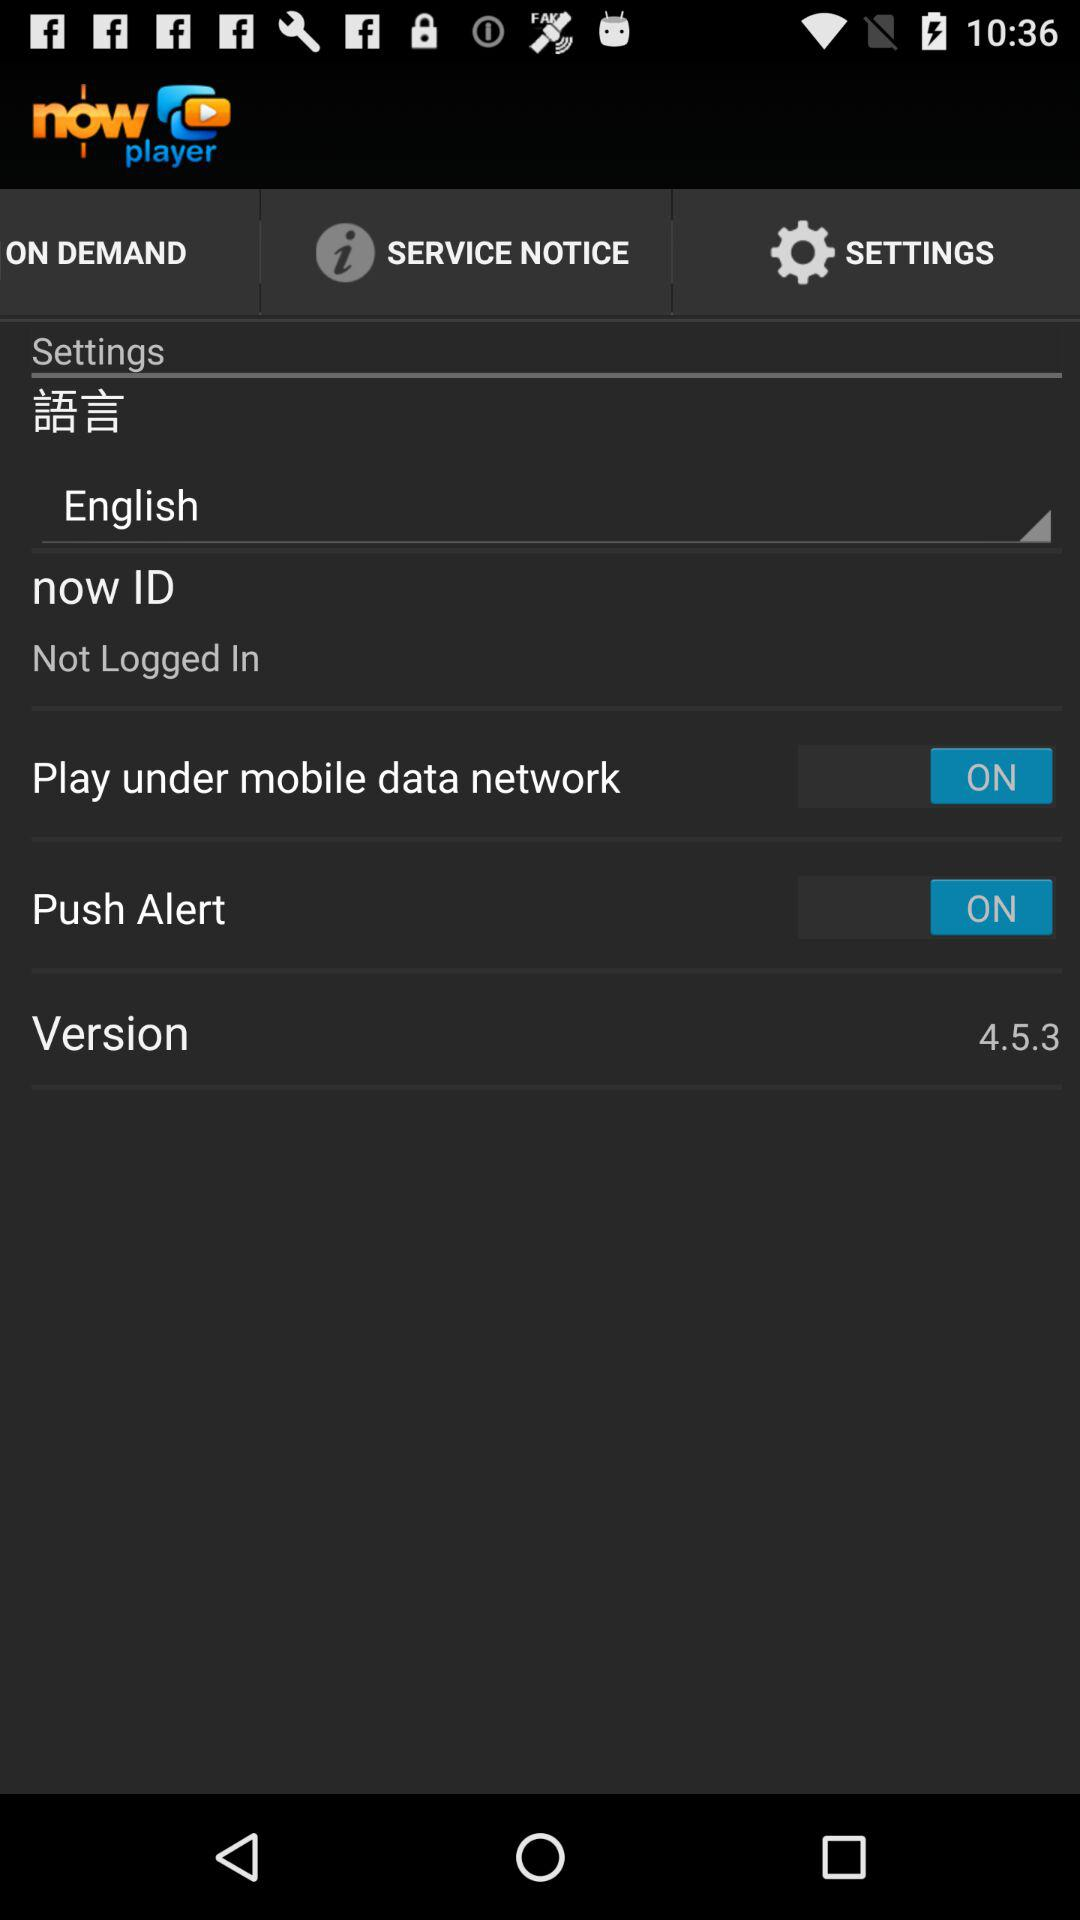What is the application name? The application name is "Now Player". 